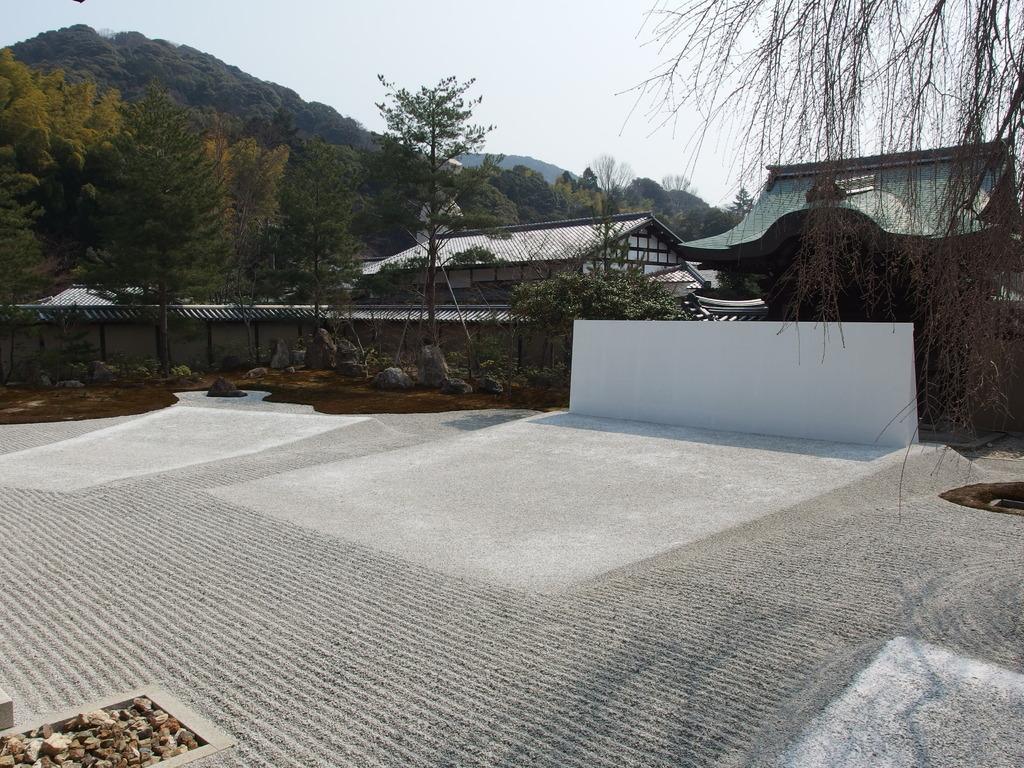In one or two sentences, can you explain what this image depicts? In this picture we can see the ground, wall, stones, buildings, trees, mountains and in the background we can see the sky. 